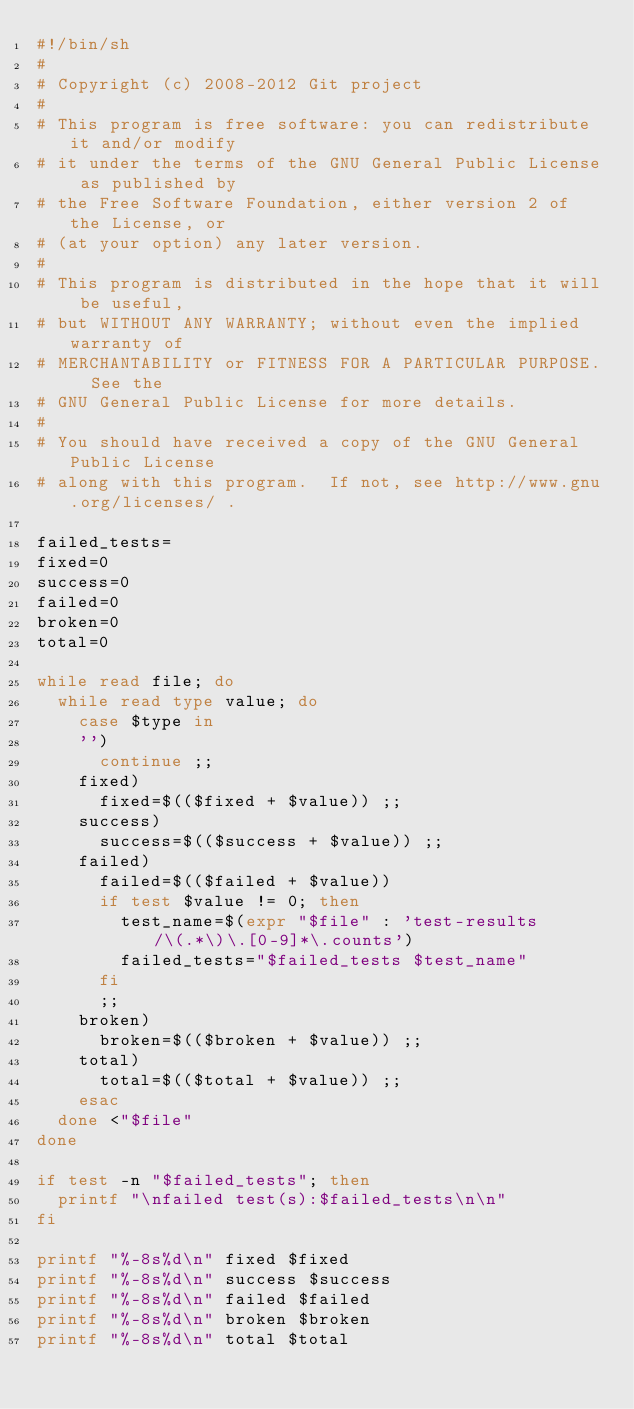Convert code to text. <code><loc_0><loc_0><loc_500><loc_500><_Bash_>#!/bin/sh
#
# Copyright (c) 2008-2012 Git project
#
# This program is free software: you can redistribute it and/or modify
# it under the terms of the GNU General Public License as published by
# the Free Software Foundation, either version 2 of the License, or
# (at your option) any later version.
#
# This program is distributed in the hope that it will be useful,
# but WITHOUT ANY WARRANTY; without even the implied warranty of
# MERCHANTABILITY or FITNESS FOR A PARTICULAR PURPOSE.  See the
# GNU General Public License for more details.
#
# You should have received a copy of the GNU General Public License
# along with this program.  If not, see http://www.gnu.org/licenses/ .

failed_tests=
fixed=0
success=0
failed=0
broken=0
total=0

while read file; do
	while read type value; do
		case $type in
		'')
			continue ;;
		fixed)
			fixed=$(($fixed + $value)) ;;
		success)
			success=$(($success + $value)) ;;
		failed)
			failed=$(($failed + $value))
			if test $value != 0; then
				test_name=$(expr "$file" : 'test-results/\(.*\)\.[0-9]*\.counts')
				failed_tests="$failed_tests $test_name"
			fi
			;;
		broken)
			broken=$(($broken + $value)) ;;
		total)
			total=$(($total + $value)) ;;
		esac
	done <"$file"
done

if test -n "$failed_tests"; then
	printf "\nfailed test(s):$failed_tests\n\n"
fi

printf "%-8s%d\n" fixed $fixed
printf "%-8s%d\n" success $success
printf "%-8s%d\n" failed $failed
printf "%-8s%d\n" broken $broken
printf "%-8s%d\n" total $total
</code> 